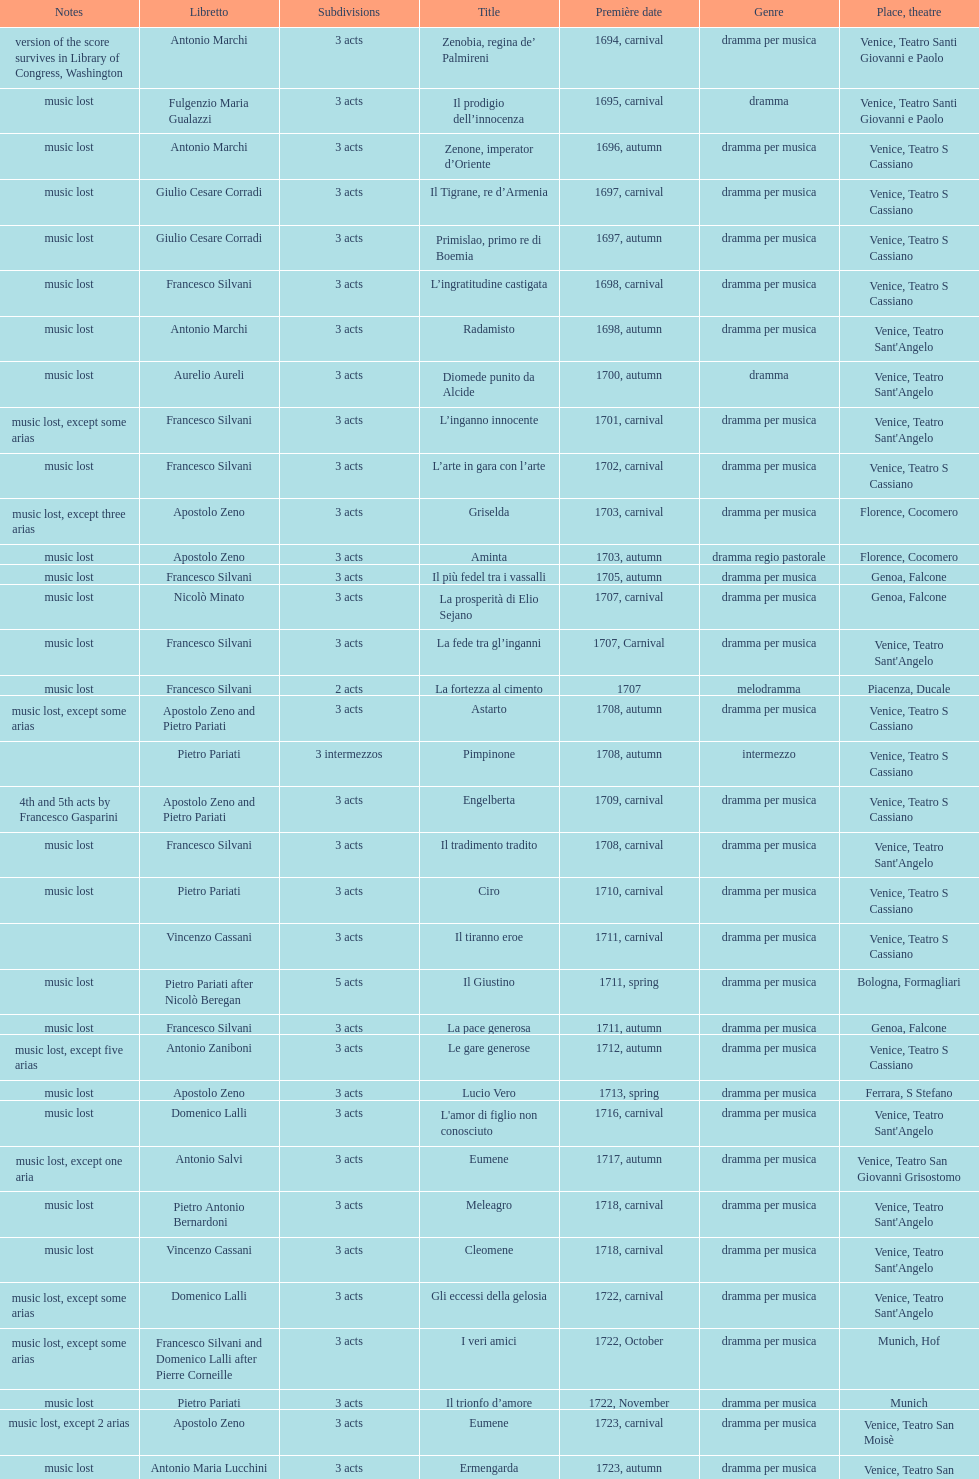What is next after ardelinda? Candalide. 